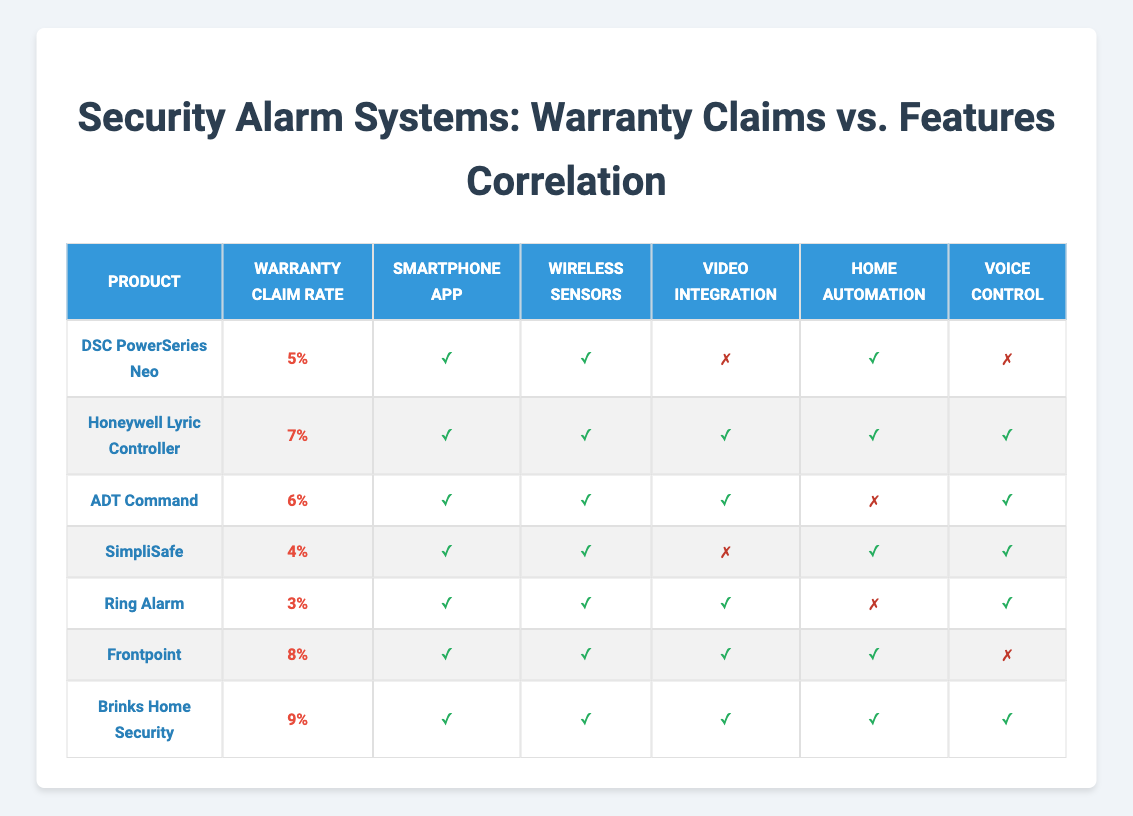What's the warranty claim rate for the DSC PowerSeries Neo? The warranty claim rate for the DSC PowerSeries Neo is listed directly in the table under the "Warranty Claim Rate" column. It shows a rate of 5%.
Answer: 5% Which products have wireless sensors feature but no voice control? To find this, check the "Wireless Sensors" and "Voice Control" columns in the table. The products that have '✓' for wireless sensors and '✗' for voice control are the DSC PowerSeries Neo and Frontpoint.
Answer: DSC PowerSeries Neo, Frontpoint What is the average warranty claim rate for products with home automation feature? First, identify products with the home automation feature marked by '✓', which are Honeywell Lyric Controller, ADT Command, SimpliSafe, Ring Alarm, Frontpoint, and Brinks Home Security. Their claim rates are 7%, 6%, 4%, 3%, 8%, and 9%. The average is calculated as (7 + 6 + 4 + 3 + 8 + 9) / 6 = 6.17%.
Answer: 6.17% Is the claim rate for the Honeywell Lyric Controller higher than the claim rate for the Ring Alarm? The claim rate for the Honeywell Lyric Controller is 7% and for the Ring Alarm is 3%. Since 7% is greater than 3%, we conclude that the claim rate for Honeywell Lyric Controller is indeed higher.
Answer: Yes How many products feature both video integration and smartphone app? Review the table for the 'Video Integration' column where it shows '✓' and check if the 'Smartphone App' also has '✓'. The products with both features are Honeywell Lyric Controller, ADT Command, Frontpoint, and Brinks Home Security. There are four such products.
Answer: 4 